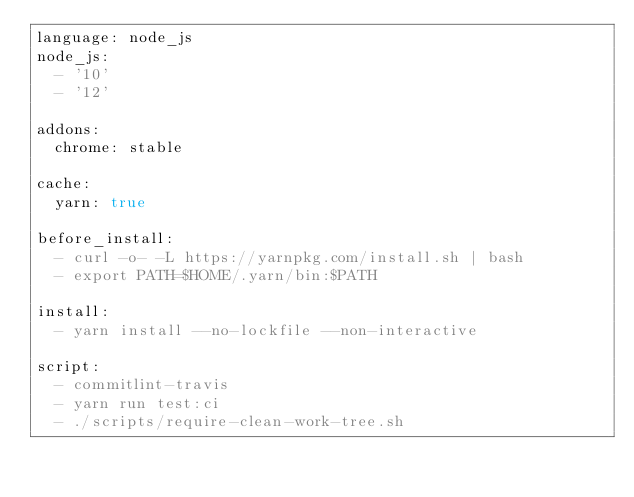<code> <loc_0><loc_0><loc_500><loc_500><_YAML_>language: node_js
node_js:
  - '10'
  - '12'

addons:
  chrome: stable

cache:
  yarn: true

before_install:
  - curl -o- -L https://yarnpkg.com/install.sh | bash
  - export PATH=$HOME/.yarn/bin:$PATH

install:
  - yarn install --no-lockfile --non-interactive

script:
  - commitlint-travis
  - yarn run test:ci
  - ./scripts/require-clean-work-tree.sh
</code> 